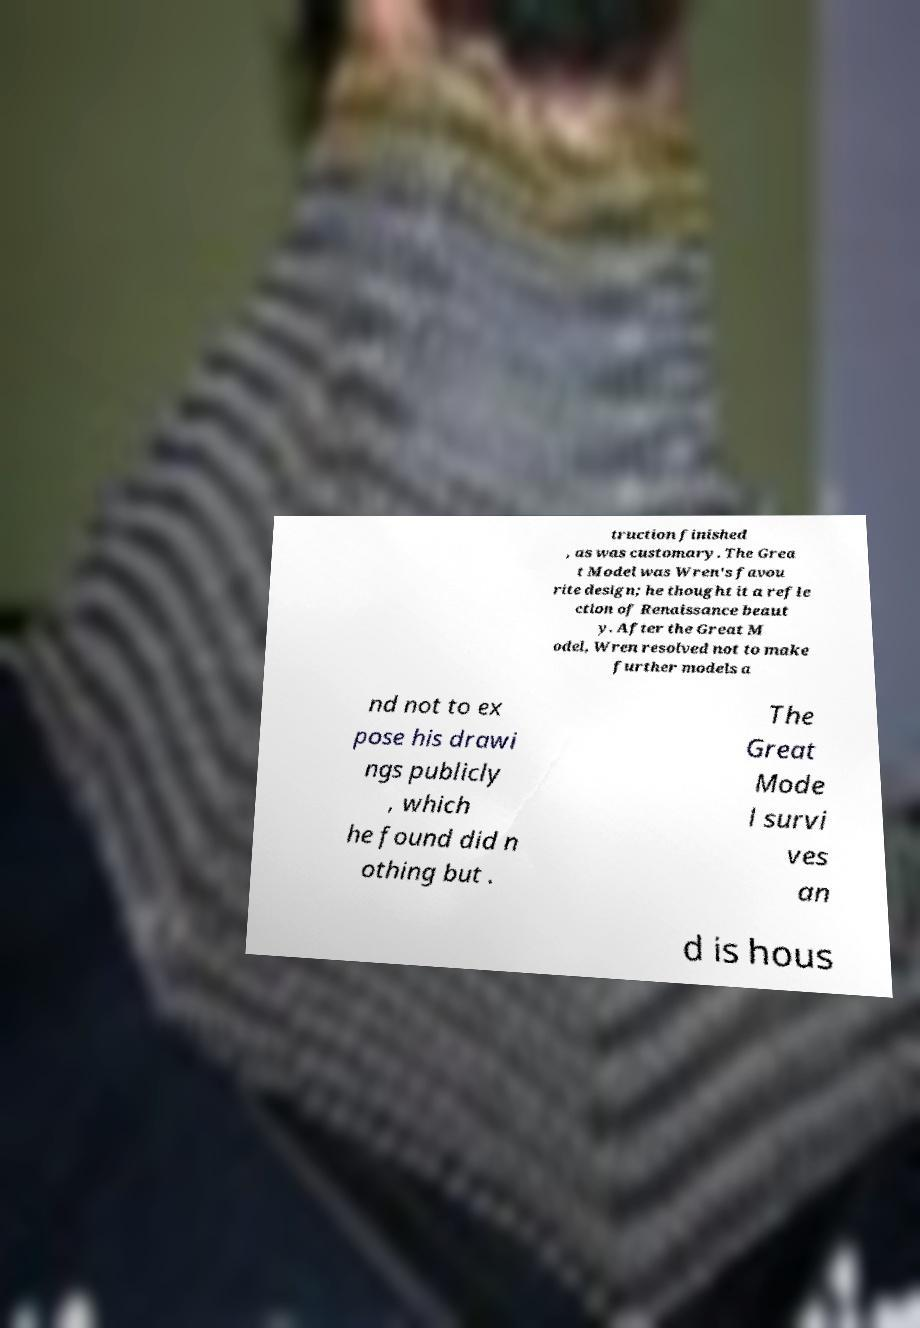Could you assist in decoding the text presented in this image and type it out clearly? truction finished , as was customary. The Grea t Model was Wren's favou rite design; he thought it a refle ction of Renaissance beaut y. After the Great M odel, Wren resolved not to make further models a nd not to ex pose his drawi ngs publicly , which he found did n othing but . The Great Mode l survi ves an d is hous 